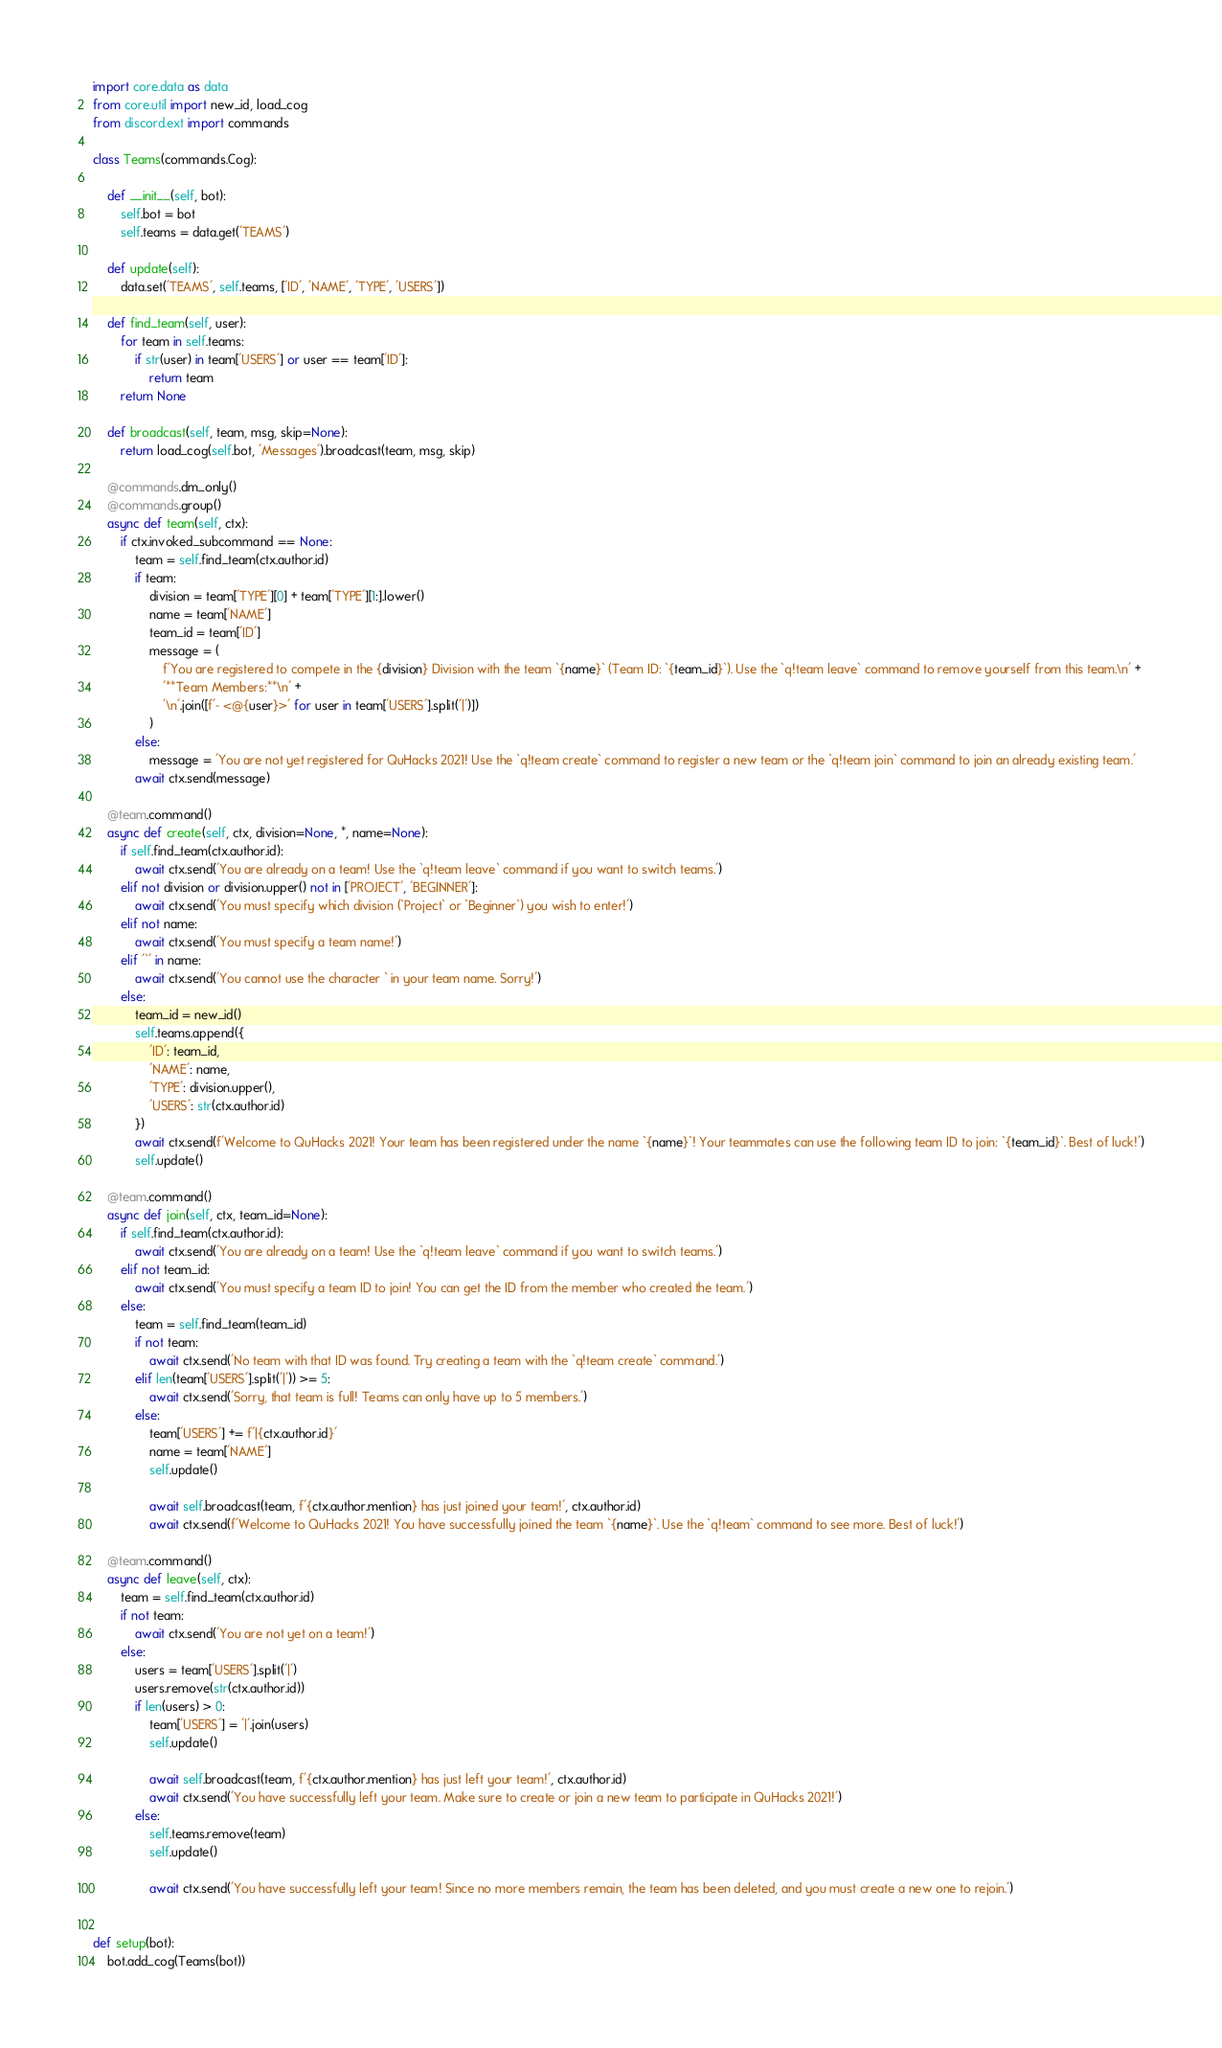Convert code to text. <code><loc_0><loc_0><loc_500><loc_500><_Python_>import core.data as data
from core.util import new_id, load_cog
from discord.ext import commands

class Teams(commands.Cog):
    
    def __init__(self, bot):
        self.bot = bot
        self.teams = data.get('TEAMS')

    def update(self):
        data.set('TEAMS', self.teams, ['ID', 'NAME', 'TYPE', 'USERS'])

    def find_team(self, user):
        for team in self.teams:
            if str(user) in team['USERS'] or user == team['ID']:
                return team
        return None

    def broadcast(self, team, msg, skip=None):
        return load_cog(self.bot, 'Messages').broadcast(team, msg, skip)

    @commands.dm_only()
    @commands.group()
    async def team(self, ctx):
        if ctx.invoked_subcommand == None:
            team = self.find_team(ctx.author.id)
            if team:
                division = team['TYPE'][0] + team['TYPE'][1:].lower()
                name = team['NAME']
                team_id = team['ID']
                message = (
                    f'You are registered to compete in the {division} Division with the team `{name}` (Team ID: `{team_id}`). Use the `q!team leave` command to remove yourself from this team.\n' +
                    '**Team Members:**\n' +
                    '\n'.join([f'- <@{user}>' for user in team['USERS'].split('|')])
                )
            else:
                message = 'You are not yet registered for QuHacks 2021! Use the `q!team create` command to register a new team or the `q!team join` command to join an already existing team.'
            await ctx.send(message)

    @team.command()
    async def create(self, ctx, division=None, *, name=None):
        if self.find_team(ctx.author.id):
            await ctx.send('You are already on a team! Use the `q!team leave` command if you want to switch teams.')
        elif not division or division.upper() not in ['PROJECT', 'BEGINNER']:
            await ctx.send('You must specify which division (`Project` or `Beginner`) you wish to enter!')
        elif not name:
            await ctx.send('You must specify a team name!')
        elif '`' in name:
            await ctx.send('You cannot use the character ` in your team name. Sorry!')
        else:
            team_id = new_id()
            self.teams.append({
                'ID': team_id,
                'NAME': name,
                'TYPE': division.upper(),
                'USERS': str(ctx.author.id)
            })
            await ctx.send(f'Welcome to QuHacks 2021! Your team has been registered under the name `{name}`! Your teammates can use the following team ID to join: `{team_id}`. Best of luck!')
            self.update()
        
    @team.command()
    async def join(self, ctx, team_id=None):
        if self.find_team(ctx.author.id):
            await ctx.send('You are already on a team! Use the `q!team leave` command if you want to switch teams.')
        elif not team_id:
            await ctx.send('You must specify a team ID to join! You can get the ID from the member who created the team.')
        else:
            team = self.find_team(team_id)
            if not team:
                await ctx.send('No team with that ID was found. Try creating a team with the `q!team create` command.')
            elif len(team['USERS'].split('|')) >= 5:
                await ctx.send('Sorry, that team is full! Teams can only have up to 5 members.')
            else:
                team['USERS'] += f'|{ctx.author.id}'
                name = team['NAME']
                self.update()
                
                await self.broadcast(team, f'{ctx.author.mention} has just joined your team!', ctx.author.id)
                await ctx.send(f'Welcome to QuHacks 2021! You have successfully joined the team `{name}`. Use the `q!team` command to see more. Best of luck!')
    
    @team.command()
    async def leave(self, ctx):
        team = self.find_team(ctx.author.id)
        if not team:
            await ctx.send('You are not yet on a team!')
        else:
            users = team['USERS'].split('|')
            users.remove(str(ctx.author.id))
            if len(users) > 0:
                team['USERS'] = '|'.join(users)
                self.update()

                await self.broadcast(team, f'{ctx.author.mention} has just left your team!', ctx.author.id)
                await ctx.send('You have successfully left your team. Make sure to create or join a new team to participate in QuHacks 2021!')
            else:
                self.teams.remove(team)
                self.update()

                await ctx.send('You have successfully left your team! Since no more members remain, the team has been deleted, and you must create a new one to rejoin.')
            

def setup(bot):
    bot.add_cog(Teams(bot))</code> 